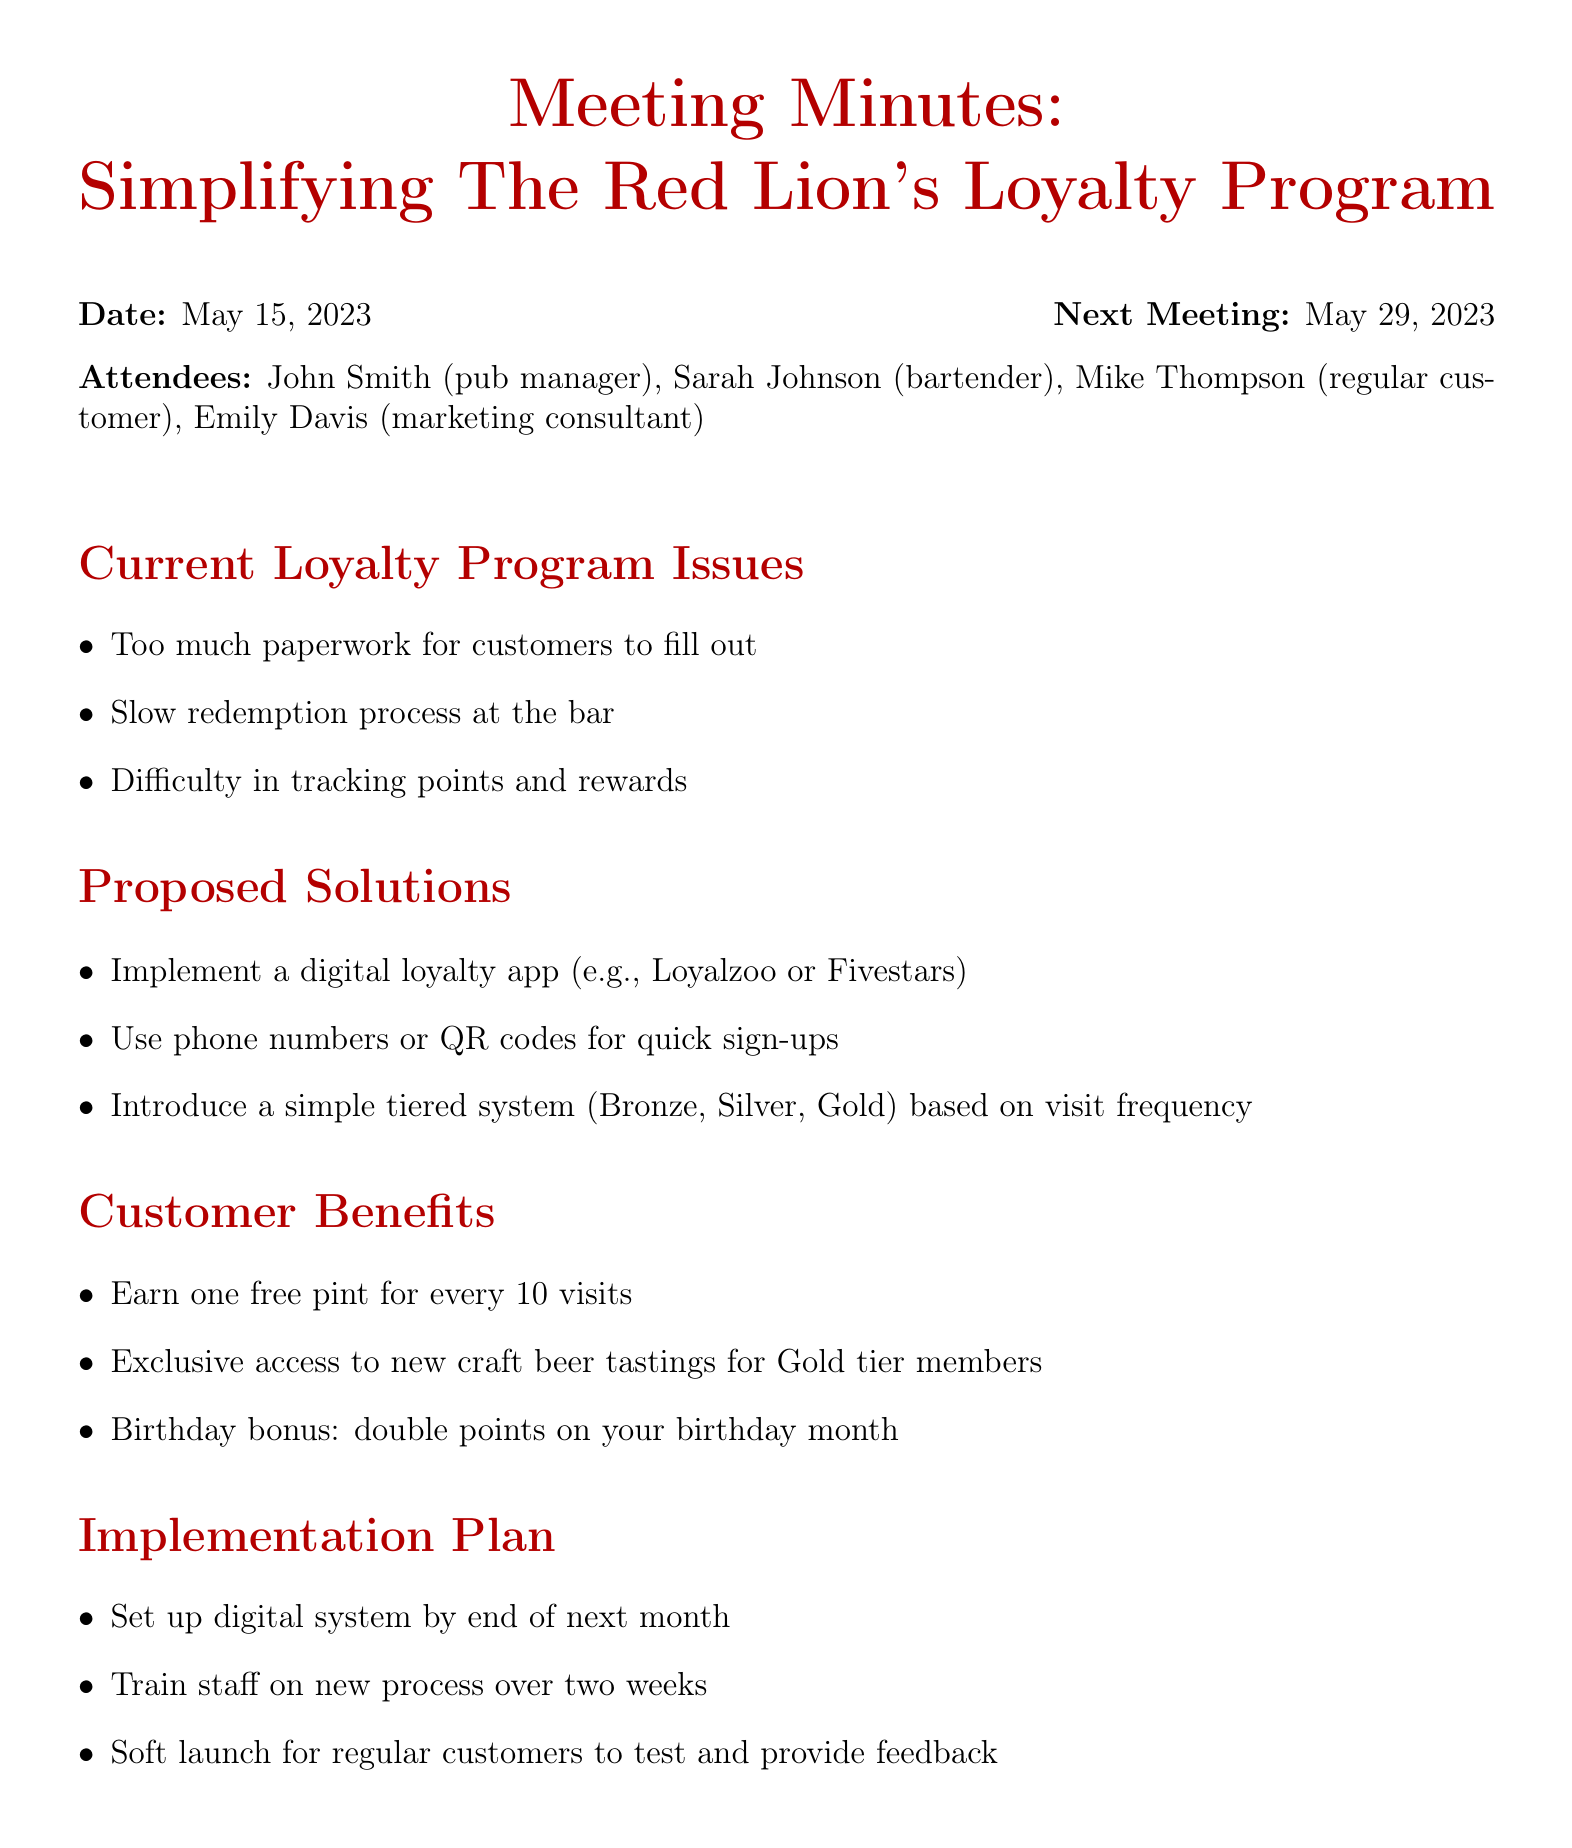What is the date of the meeting? The meeting was held on May 15, 2023, as indicated in the document.
Answer: May 15, 2023 Who is the pub manager? The document lists John Smith as the pub manager among the attendees.
Answer: John Smith What are the customer benefits? The document outlines specific benefits for customers under the "Customer Benefits" section.
Answer: Earn one free pint for every 10 visits What is one proposed solution for the loyalty program? The document provides multiple proposed solutions for simplifying the loyalty program.
Answer: Implement a digital loyalty app When is the next meeting scheduled? The date of the next meeting is mentioned at the end of the document.
Answer: May 29, 2023 Who is responsible for gathering feedback from other regulars? The action items section specifies who is tasked with gathering feedback.
Answer: Mike What are the action items listed? The document presents a series of actionable tasks that attendees are assigned, particularly in the action items section.
Answer: John to research and select appropriate loyalty app What is the proposed implementation timeline? The document mentions a plan regarding the timeframe for setting up the digital system.
Answer: Set up digital system by end of next month What loyalty tiers are introduced in the proposed system? The document specifies a simple tiered system as part of the proposed solutions.
Answer: Bronze, Silver, Gold 